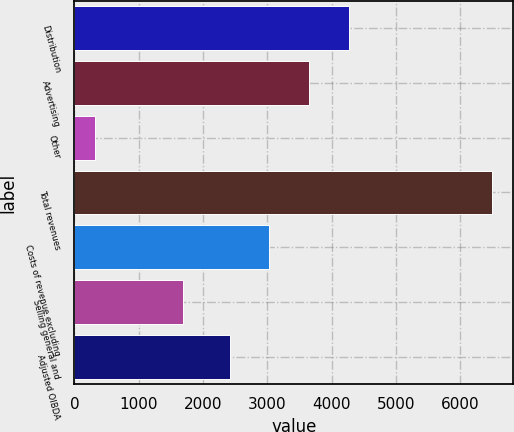Convert chart. <chart><loc_0><loc_0><loc_500><loc_500><bar_chart><fcel>Distribution<fcel>Advertising<fcel>Other<fcel>Total revenues<fcel>Costs of revenue excluding<fcel>Selling general and<fcel>Adjusted OIBDA<nl><fcel>4267.9<fcel>3649.6<fcel>314<fcel>6497<fcel>3031.3<fcel>1690<fcel>2413<nl></chart> 